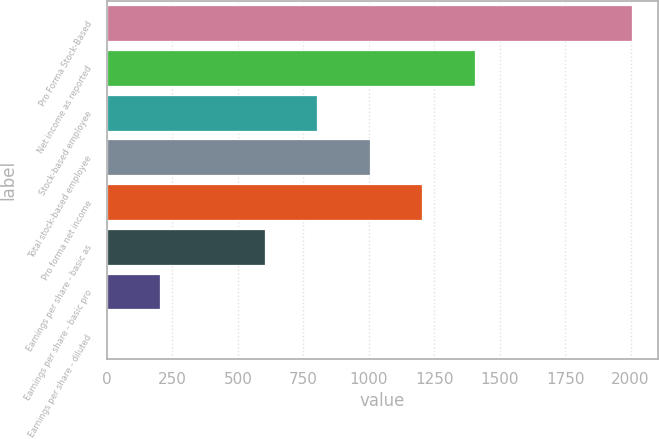Convert chart to OTSL. <chart><loc_0><loc_0><loc_500><loc_500><bar_chart><fcel>Pro Forma Stock-Based<fcel>Net income as reported<fcel>Stock-based employee<fcel>Total stock-based employee<fcel>Pro forma net income<fcel>Earnings per share - basic as<fcel>Earnings per share - basic pro<fcel>Earnings per share - diluted<nl><fcel>2005<fcel>1404.62<fcel>804.23<fcel>1004.36<fcel>1204.49<fcel>604.1<fcel>203.84<fcel>3.71<nl></chart> 